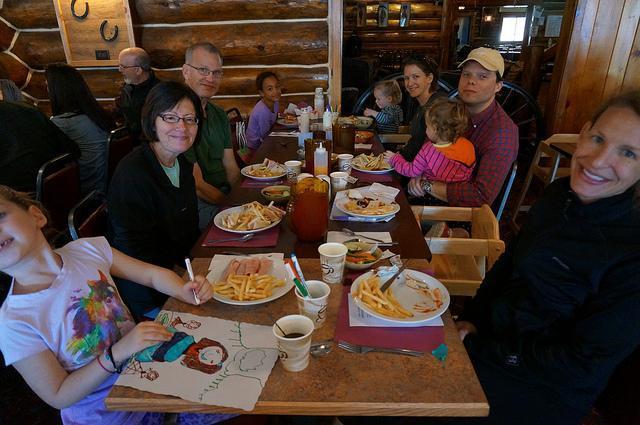How many children are in the photo?
Give a very brief answer. 4. How many people are in the picture?
Give a very brief answer. 12. How many people are at the table?
Give a very brief answer. 9. How many children are there?
Give a very brief answer. 4. How many plates are on the table?
Give a very brief answer. 8. How many plates of fries are there?
Give a very brief answer. 6. How many bright green chairs are shown?
Give a very brief answer. 0. How many people are wearing glasses?
Give a very brief answer. 3. How many women are sitting at the table?
Give a very brief answer. 3. How many people are there?
Give a very brief answer. 10. How many chairs are visible?
Give a very brief answer. 3. 